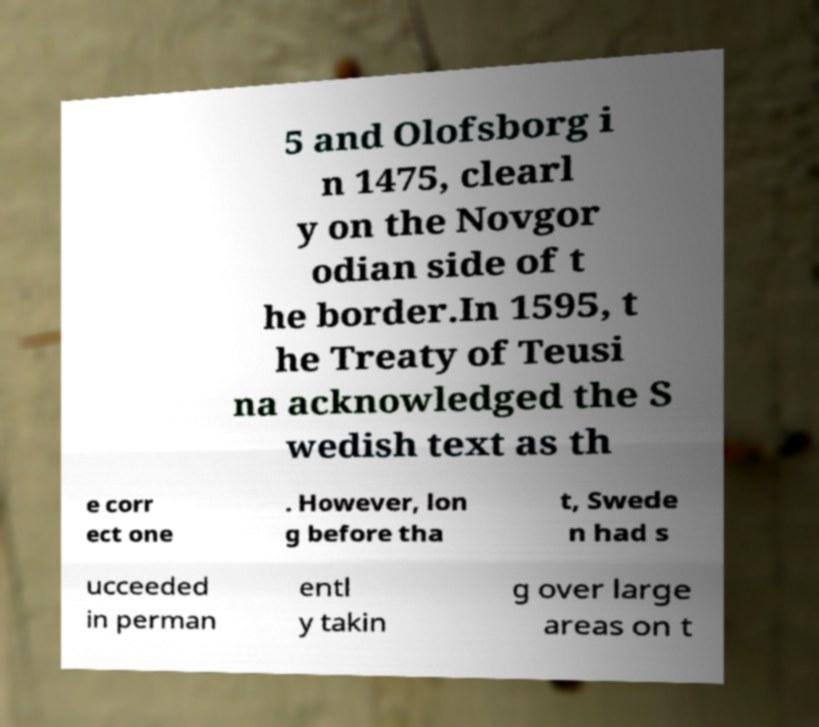Can you accurately transcribe the text from the provided image for me? 5 and Olofsborg i n 1475, clearl y on the Novgor odian side of t he border.In 1595, t he Treaty of Teusi na acknowledged the S wedish text as th e corr ect one . However, lon g before tha t, Swede n had s ucceeded in perman entl y takin g over large areas on t 